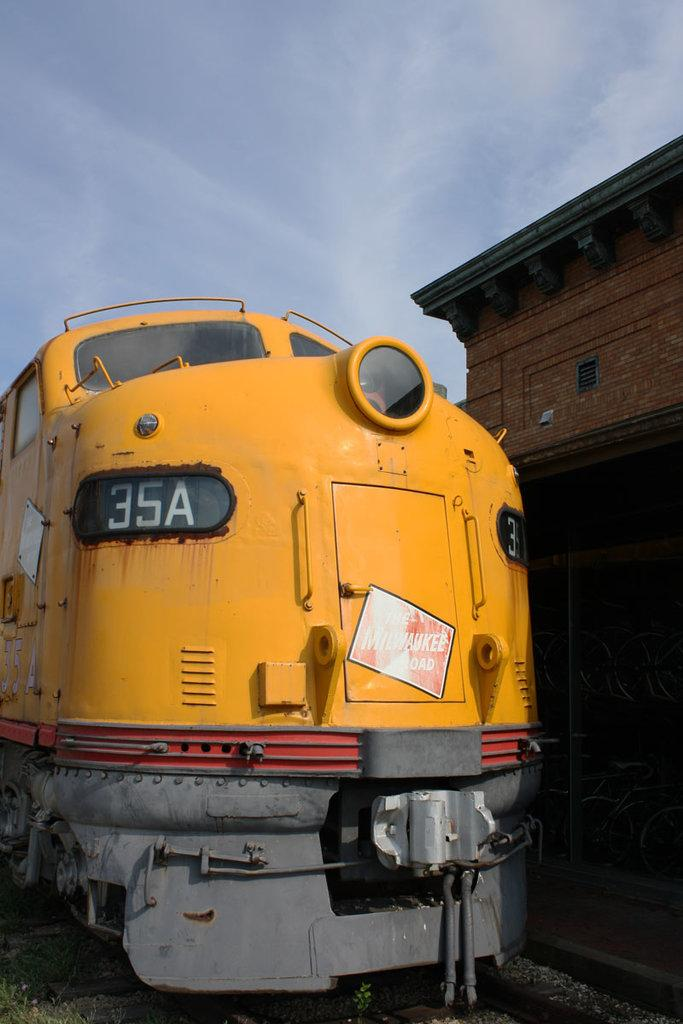<image>
Provide a brief description of the given image. Train engine 35A is on the tracks and is yellow. 